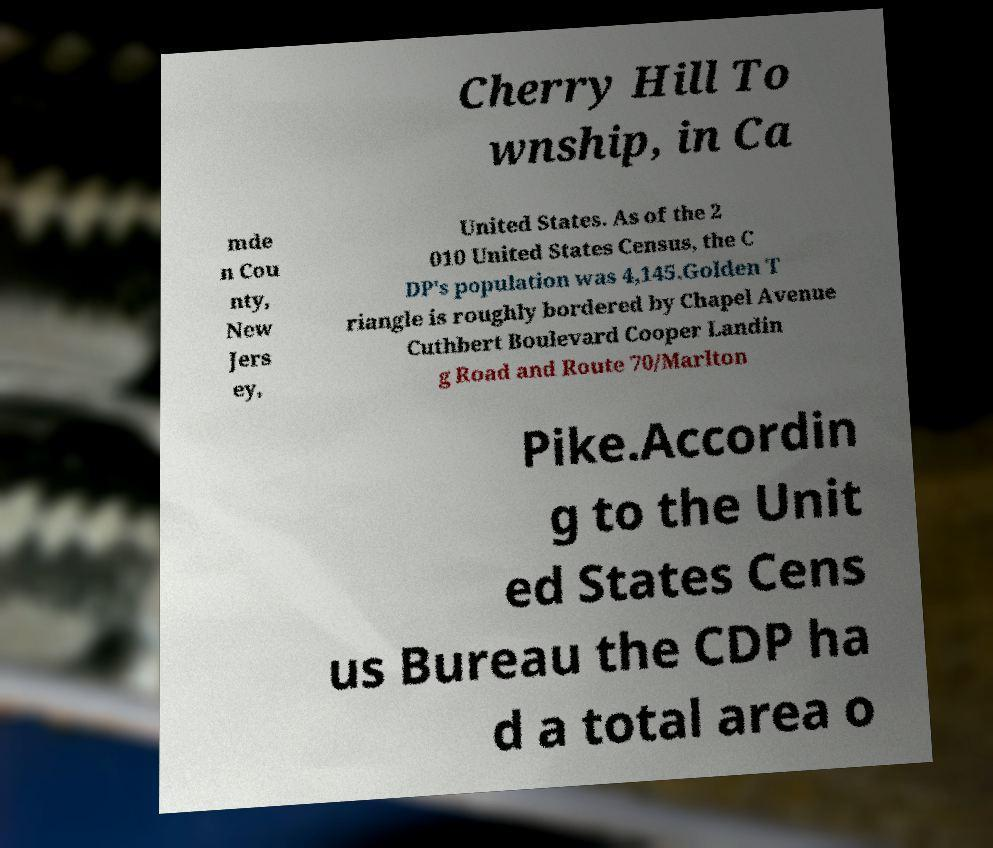Could you assist in decoding the text presented in this image and type it out clearly? Cherry Hill To wnship, in Ca mde n Cou nty, New Jers ey, United States. As of the 2 010 United States Census, the C DP's population was 4,145.Golden T riangle is roughly bordered by Chapel Avenue Cuthbert Boulevard Cooper Landin g Road and Route 70/Marlton Pike.Accordin g to the Unit ed States Cens us Bureau the CDP ha d a total area o 